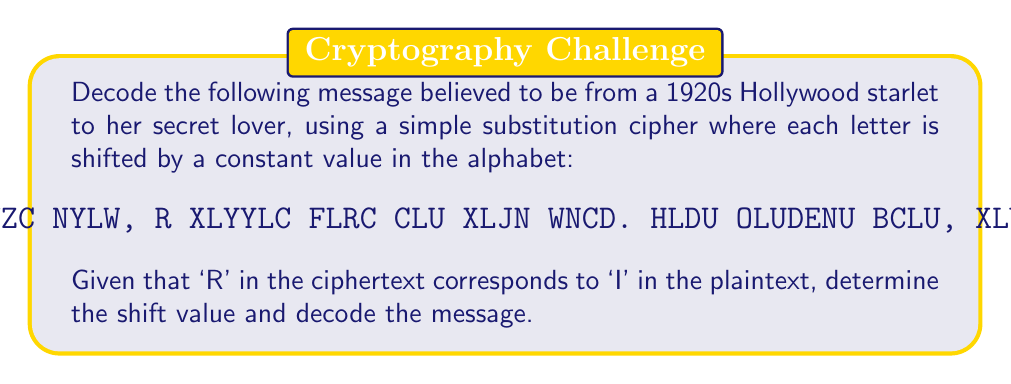Can you solve this math problem? To solve this substitution cipher, we'll follow these steps:

1) First, we need to find the shift value. We're given that 'R' in the ciphertext corresponds to 'I' in the plaintext.

   In the alphabet, R is the 18th letter and I is the 9th letter.
   Shift value = 18 - 9 = 9

2) To decode, we need to shift each letter back by 9 positions in the alphabet.

3) Let's create a decoding table:
   A → R, B → S, C → T, D → U, E → V, F → W, G → X, H → Y, I → Z, 
   J → A, K → B, L → C, M → D, N → E, O → F, P → G, Q → H, 
   R → I, S → J, T → K, U → L, V → M, W → N, X → O, Y → P, Z → Q

4) Now, let's decode each word:
   MYZC → DEAR
   NYLW → EARL
   R → I
   XLYYLC → CANNOT
   FLRC → WAIT
   CLU → FOR
   XLJN → COME
   WNCD → SOON
   HLDU → YOUR
   OLUDENU → FOREVER
   BCLU → STAR
   XLUL → CORA

5) The fully decoded message reads:
   "DEAR EARL, I CANNOT WAIT FOR COME SOON. YOUR FOREVER STAR, CORA"
Answer: Shift value: 9; Decoded message: "DEAR EARL, I CANNOT WAIT FOR COME SOON. YOUR FOREVER STAR, CORA" 